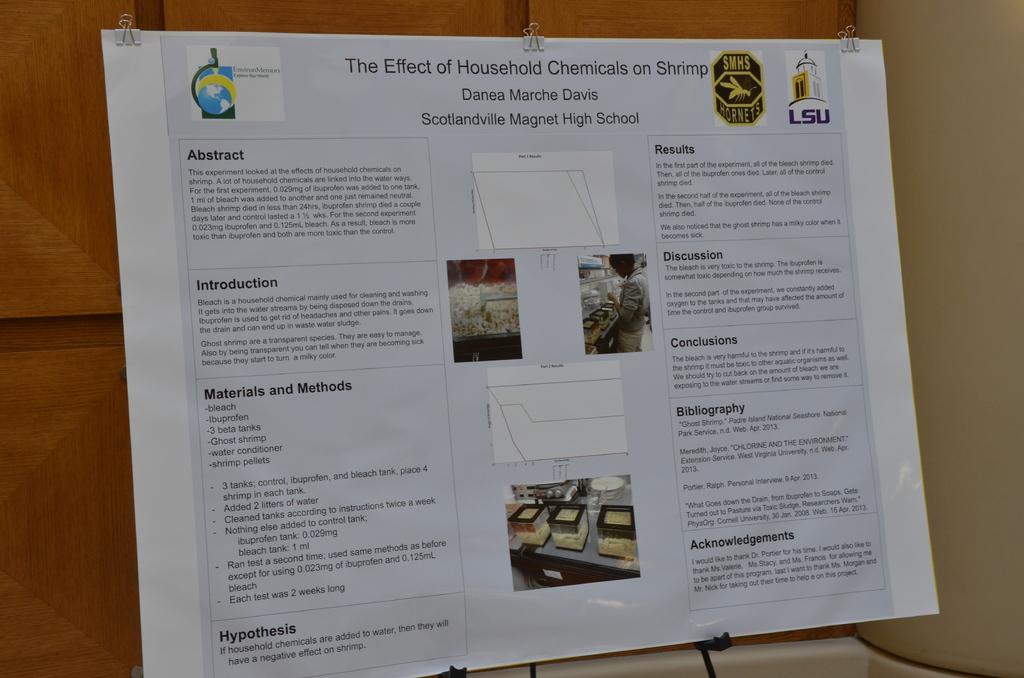What high school is this for?
Make the answer very short. Scotlandville magnet high school. What is the title of this poster?
Provide a short and direct response. The effect of household chemicals on shrimp. 